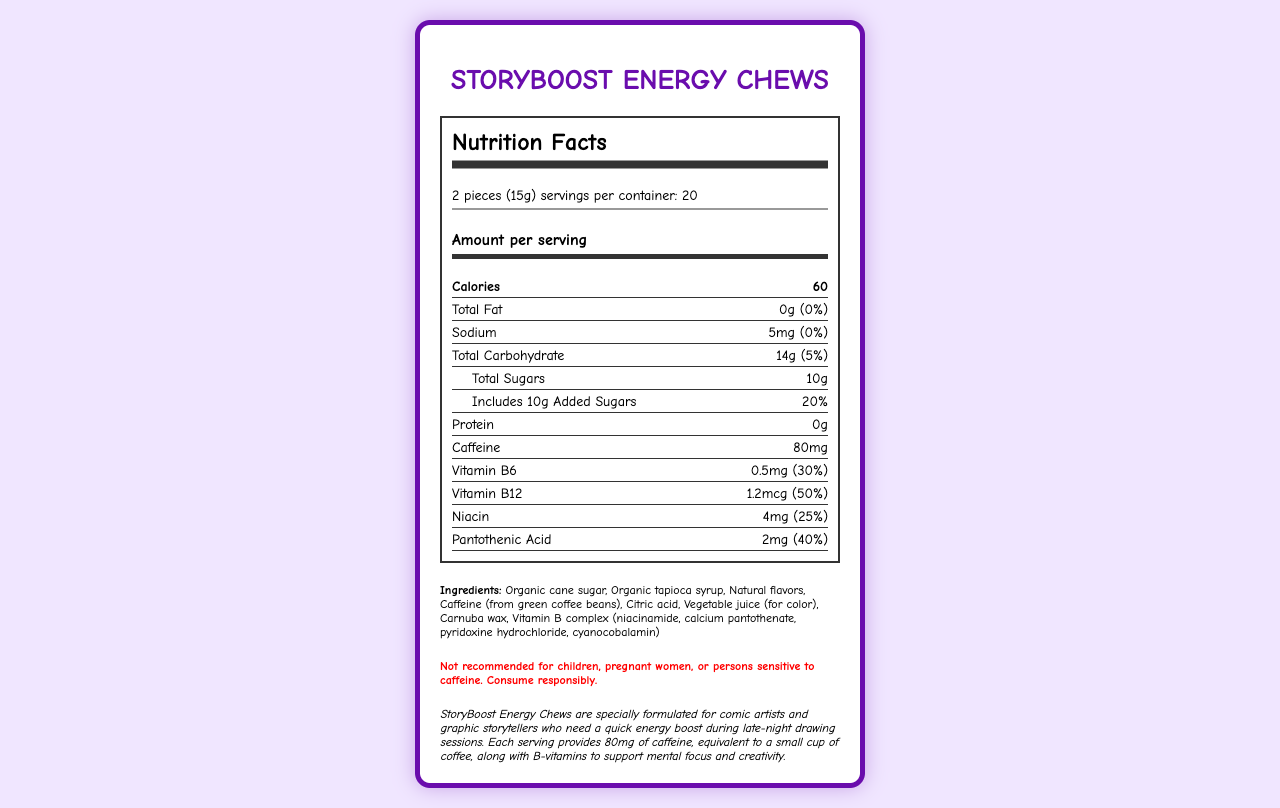what is the serving size for StoryBoost Energy Chews? The serving size is listed as "2 pieces (15g)" in the nutrition label section of the document.
Answer: 2 pieces (15g) how many calories are in one serving of StoryBoost Energy Chews? The amount per serving indicates that each serving contains 60 calories.
Answer: 60 calories how much Vitamin B6 is in one serving of this product? The nutrition label shows that each serving contains 0.5mg of Vitamin B6.
Answer: 0.5mg how many servings are there per container? The document states there are 20 servings per container.
Answer: 20 how much added sugar is in one serving? The nutrition label specifies that one serving includes 10g of added sugars.
Answer: 10g which vitamin has the highest daily value percentage in this product? A. Vitamin B6 B. Vitamin B12 C. Niacin D. Pantothenic Acid Vitamin B12 has a daily value percentage of 50%, which is higher than Vitamin B6 (30%), Niacin (25%), and Pantothenic Acid (40%).
Answer: B how much sodium is in a serving? A. 5mg B. 10mg C. 20mg D. 25mg The nutrition label lists the sodium content per serving as 5mg.
Answer: A is this product recommended for children? The warning section explicitly states that the product is not recommended for children, among others.
Answer: No describe the main purpose of StoryBoost Energy Chews. The product description explains that StoryBoost Energy Chews are formulated to offer energy and support mental focus and creativity during late-night drawing sessions.
Answer: To provide a quick energy boost for comic artists and graphic storytellers during late-night drawing sessions. what is the source of caffeine in these chews? The ingredients list in the document specifies that the caffeine comes from green coffee beans.
Answer: Green coffee beans can this product be consumed by someone who is allergic to soy? The allergen info states that the product is produced in a facility that processes soy, but it does not confirm if the product itself contains soy.
Answer: Not enough information what is the total carbohydrate amount in one serving? The nutrition label shows that the total carbohydrate content per serving is 14g.
Answer: 14g what are the main ingredients responsible for the energy boost in the chews? The product description and ingredients list indicate caffeine (from green coffee beans) and Vitamin B complex (niacinamide, calcium pantothenate, pyridoxine hydrochloride, cyanocobalamin) as key contributors to the energy boost.
Answer: Caffeine and Vitamin B complex 